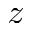Convert formula to latex. <formula><loc_0><loc_0><loc_500><loc_500>z</formula> 